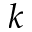Convert formula to latex. <formula><loc_0><loc_0><loc_500><loc_500>k</formula> 